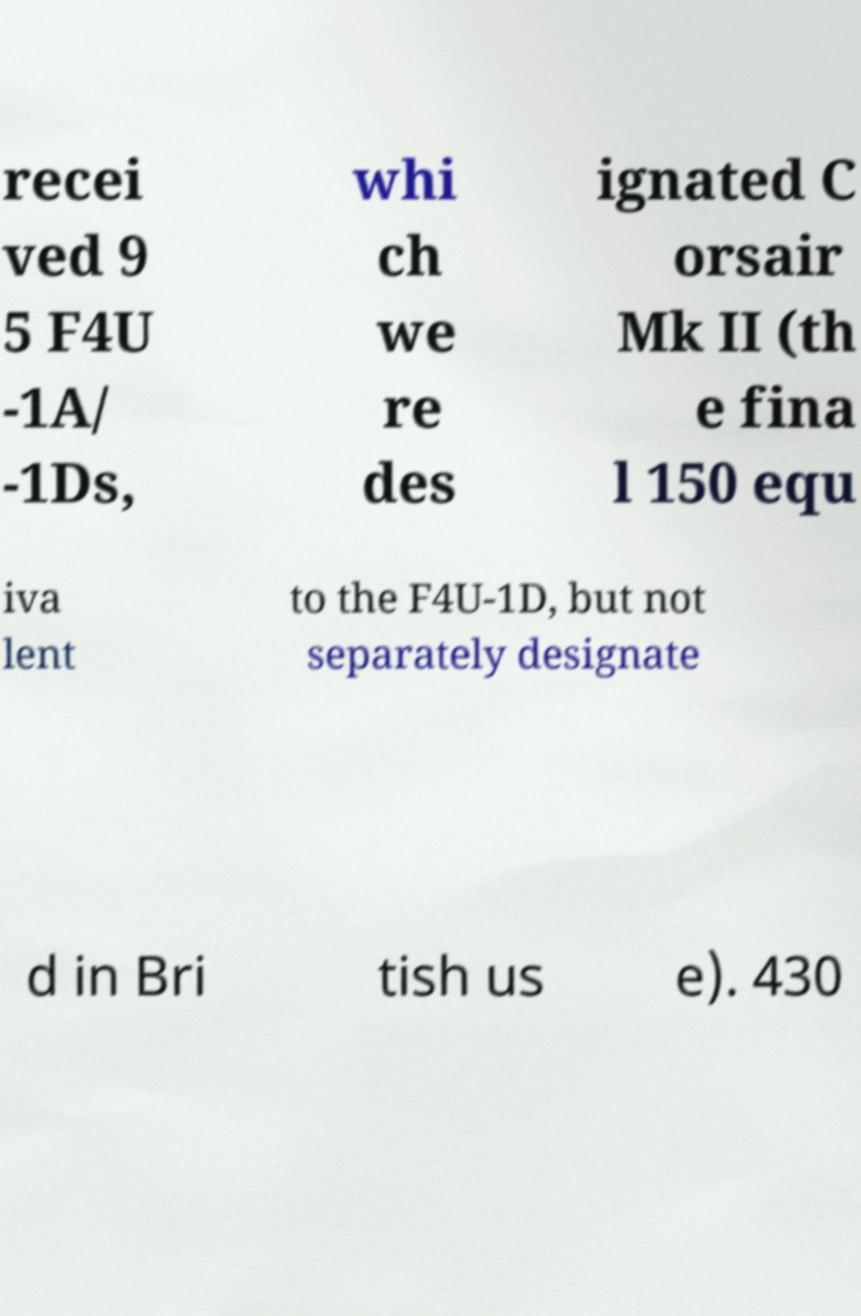Can you accurately transcribe the text from the provided image for me? recei ved 9 5 F4U -1A/ -1Ds, whi ch we re des ignated C orsair Mk II (th e fina l 150 equ iva lent to the F4U-1D, but not separately designate d in Bri tish us e). 430 